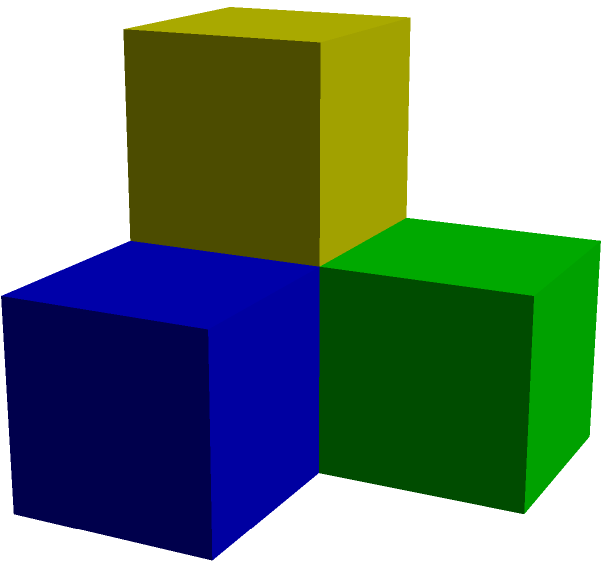As a child advocate, you're designing a spatial reasoning activity for children. The image shows a structure made of colored blocks from two different angles: front and top. If a yellow block is placed directly on top of a red block, what color block would be touching both the blue and green blocks? Let's analyze this step-by-step:

1. From the front view, we can see:
   - A red block at the bottom
   - A blue block to the right of the red block
   - A yellow block on top of the red block

2. From the top view, we can see:
   - A red block
   - A blue block to the right of the red block
   - A green block behind the red block
   - A yellow block on top of the red block

3. We need to visualize how these blocks are arranged in 3D space:
   - The red block is at the bottom front left corner
   - The blue block is to the right of the red block
   - The green block is behind the red block
   - The yellow block is on top of the red block

4. The question asks about a block that would touch both the blue and green blocks:
   - This block would need to be diagonally adjacent to both blue and green blocks
   - The only position that satisfies this is above the red block and diagonally between the blue and green blocks

5. We already know there's a yellow block on top of the red block

Therefore, the yellow block is the one touching both the blue and green blocks.
Answer: Yellow 